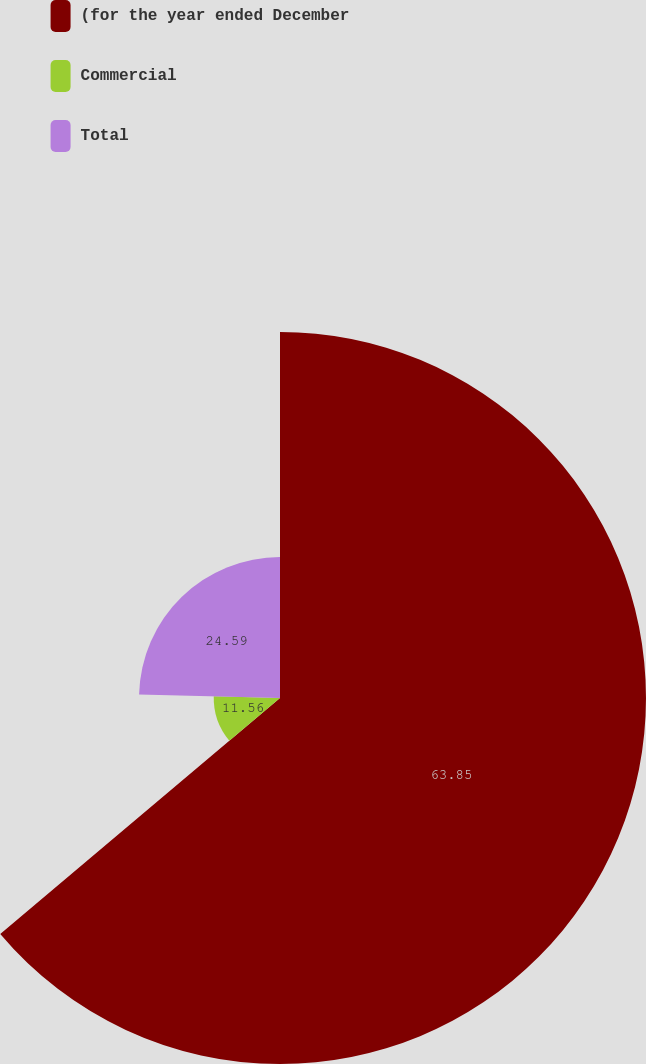Convert chart. <chart><loc_0><loc_0><loc_500><loc_500><pie_chart><fcel>(for the year ended December<fcel>Commercial<fcel>Total<nl><fcel>63.84%<fcel>11.56%<fcel>24.59%<nl></chart> 